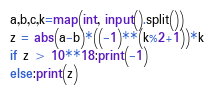<code> <loc_0><loc_0><loc_500><loc_500><_Python_>a,b,c,k=map(int, input().split())
z = abs(a-b)*((-1)**(k%2+1))*k
if z > 10**18:print(-1)
else:print(z)</code> 